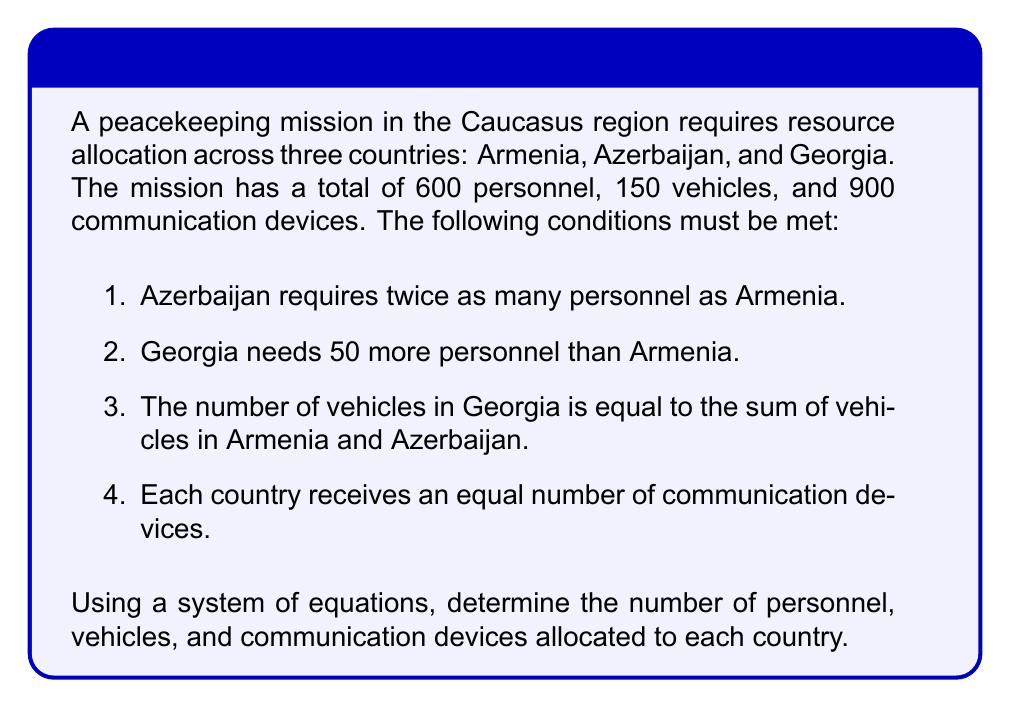Provide a solution to this math problem. Let's define our variables:
$a$, $b$, $g$ = number of personnel in Armenia, Azerbaijan, and Georgia respectively
$v_a$, $v_b$, $v_g$ = number of vehicles in Armenia, Azerbaijan, and Georgia respectively
$c$ = number of communication devices per country

Step 1: Set up equations based on the given conditions:
1. $b = 2a$
2. $g = a + 50$
3. $a + b + g = 600$ (total personnel)
4. $v_g = v_a + v_b$
5. $v_a + v_b + v_g = 150$ (total vehicles)
6. $3c = 900$ (total communication devices)

Step 2: Solve for personnel allocation
Substitute equations 1 and 2 into equation 3:
$a + 2a + (a + 50) = 600$
$4a + 50 = 600$
$4a = 550$
$a = 137.5$

Round to the nearest whole number: $a = 138$

Now we can calculate $b$ and $g$:
$b = 2a = 2(138) = 276$
$g = a + 50 = 138 + 50 = 188$

Step 3: Solve for vehicle allocation
From equation 4 and 5:
$v_g = v_a + v_b$ and $v_a + v_b + v_g = 150$
Substitute the first equation into the second:
$v_a + v_b + (v_a + v_b) = 150$
$2(v_a + v_b) = 150$
$v_a + v_b = 75$

Since $v_g = v_a + v_b$, we know $v_g = 75$

Assuming equal distribution of the remaining vehicles:
$v_a = v_b = \frac{75}{2} = 37.5$

Round to the nearest whole number: $v_a = v_b = 38$ and $v_g = 74$

Step 4: Solve for communication device allocation
From equation 6:
$3c = 900$
$c = 300$

Therefore, each country receives 300 communication devices.
Answer: Armenia: 138 personnel, 38 vehicles, 300 devices
Azerbaijan: 276 personnel, 38 vehicles, 300 devices
Georgia: 188 personnel, 74 vehicles, 300 devices 